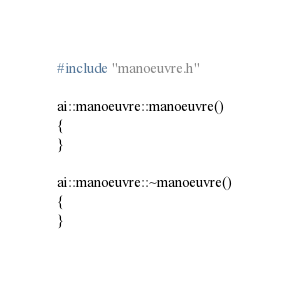<code> <loc_0><loc_0><loc_500><loc_500><_C++_>#include "manoeuvre.h"

ai::manoeuvre::manoeuvre()
{
}

ai::manoeuvre::~manoeuvre()
{
}
</code> 